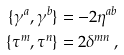Convert formula to latex. <formula><loc_0><loc_0><loc_500><loc_500>\{ \gamma ^ { a } , \gamma ^ { b } \} & = - 2 \eta ^ { a b } \\ \{ \tau ^ { m } , \tau ^ { n } \} & = 2 \delta ^ { m n } \, ,</formula> 